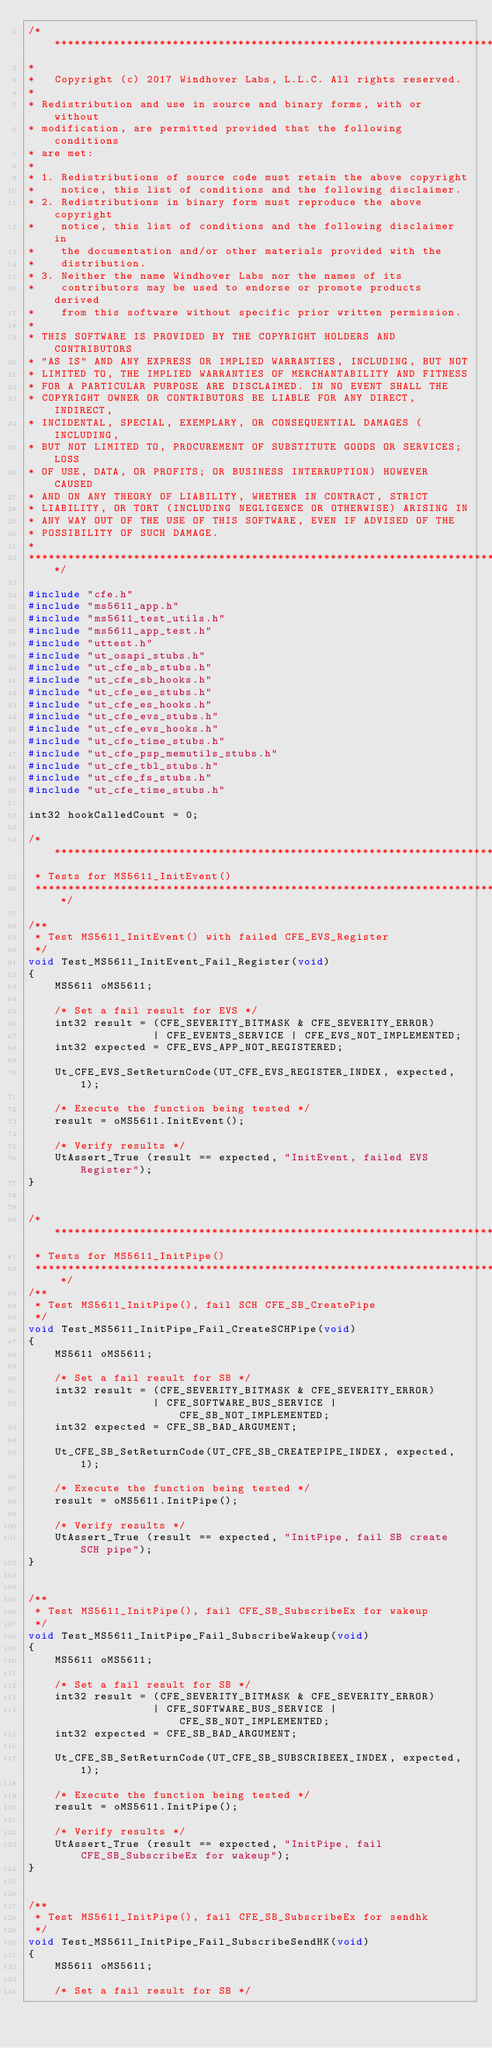<code> <loc_0><loc_0><loc_500><loc_500><_C++_>/****************************************************************************
*
*   Copyright (c) 2017 Windhover Labs, L.L.C. All rights reserved.
*
* Redistribution and use in source and binary forms, with or without
* modification, are permitted provided that the following conditions
* are met:
*
* 1. Redistributions of source code must retain the above copyright
*    notice, this list of conditions and the following disclaimer.
* 2. Redistributions in binary form must reproduce the above copyright
*    notice, this list of conditions and the following disclaimer in
*    the documentation and/or other materials provided with the
*    distribution.
* 3. Neither the name Windhover Labs nor the names of its
*    contributors may be used to endorse or promote products derived
*    from this software without specific prior written permission.
*
* THIS SOFTWARE IS PROVIDED BY THE COPYRIGHT HOLDERS AND CONTRIBUTORS
* "AS IS" AND ANY EXPRESS OR IMPLIED WARRANTIES, INCLUDING, BUT NOT
* LIMITED TO, THE IMPLIED WARRANTIES OF MERCHANTABILITY AND FITNESS
* FOR A PARTICULAR PURPOSE ARE DISCLAIMED. IN NO EVENT SHALL THE
* COPYRIGHT OWNER OR CONTRIBUTORS BE LIABLE FOR ANY DIRECT, INDIRECT,
* INCIDENTAL, SPECIAL, EXEMPLARY, OR CONSEQUENTIAL DAMAGES (INCLUDING,
* BUT NOT LIMITED TO, PROCUREMENT OF SUBSTITUTE GOODS OR SERVICES; LOSS
* OF USE, DATA, OR PROFITS; OR BUSINESS INTERRUPTION) HOWEVER CAUSED
* AND ON ANY THEORY OF LIABILITY, WHETHER IN CONTRACT, STRICT
* LIABILITY, OR TORT (INCLUDING NEGLIGENCE OR OTHERWISE) ARISING IN
* ANY WAY OUT OF THE USE OF THIS SOFTWARE, EVEN IF ADVISED OF THE
* POSSIBILITY OF SUCH DAMAGE.
*
*****************************************************************************/

#include "cfe.h"
#include "ms5611_app.h"
#include "ms5611_test_utils.h"
#include "ms5611_app_test.h"
#include "uttest.h"
#include "ut_osapi_stubs.h"
#include "ut_cfe_sb_stubs.h"
#include "ut_cfe_sb_hooks.h"
#include "ut_cfe_es_stubs.h"
#include "ut_cfe_es_hooks.h"
#include "ut_cfe_evs_stubs.h"
#include "ut_cfe_evs_hooks.h"
#include "ut_cfe_time_stubs.h"
#include "ut_cfe_psp_memutils_stubs.h"
#include "ut_cfe_tbl_stubs.h"
#include "ut_cfe_fs_stubs.h"
#include "ut_cfe_time_stubs.h"

int32 hookCalledCount = 0;

/**************************************************************************
 * Tests for MS5611_InitEvent()
 **************************************************************************/

/**
 * Test MS5611_InitEvent() with failed CFE_EVS_Register
 */
void Test_MS5611_InitEvent_Fail_Register(void)
{
    MS5611 oMS5611;

    /* Set a fail result for EVS */
    int32 result = (CFE_SEVERITY_BITMASK & CFE_SEVERITY_ERROR)
                   | CFE_EVENTS_SERVICE | CFE_EVS_NOT_IMPLEMENTED;
    int32 expected = CFE_EVS_APP_NOT_REGISTERED;

    Ut_CFE_EVS_SetReturnCode(UT_CFE_EVS_REGISTER_INDEX, expected, 1);

    /* Execute the function being tested */
    result = oMS5611.InitEvent();

    /* Verify results */
    UtAssert_True (result == expected, "InitEvent, failed EVS Register");
}


/**************************************************************************
 * Tests for MS5611_InitPipe()
 **************************************************************************/
/**
 * Test MS5611_InitPipe(), fail SCH CFE_SB_CreatePipe
 */
void Test_MS5611_InitPipe_Fail_CreateSCHPipe(void)
{
    MS5611 oMS5611;

    /* Set a fail result for SB */
    int32 result = (CFE_SEVERITY_BITMASK & CFE_SEVERITY_ERROR)
                   | CFE_SOFTWARE_BUS_SERVICE | CFE_SB_NOT_IMPLEMENTED;
    int32 expected = CFE_SB_BAD_ARGUMENT;

    Ut_CFE_SB_SetReturnCode(UT_CFE_SB_CREATEPIPE_INDEX, expected, 1);

    /* Execute the function being tested */
    result = oMS5611.InitPipe();

    /* Verify results */
    UtAssert_True (result == expected, "InitPipe, fail SB create SCH pipe");
}


/**
 * Test MS5611_InitPipe(), fail CFE_SB_SubscribeEx for wakeup
 */
void Test_MS5611_InitPipe_Fail_SubscribeWakeup(void)
{
    MS5611 oMS5611;

    /* Set a fail result for SB */
    int32 result = (CFE_SEVERITY_BITMASK & CFE_SEVERITY_ERROR)
                   | CFE_SOFTWARE_BUS_SERVICE | CFE_SB_NOT_IMPLEMENTED;
    int32 expected = CFE_SB_BAD_ARGUMENT;

    Ut_CFE_SB_SetReturnCode(UT_CFE_SB_SUBSCRIBEEX_INDEX, expected, 1);

    /* Execute the function being tested */
    result = oMS5611.InitPipe();

    /* Verify results */
    UtAssert_True (result == expected, "InitPipe, fail CFE_SB_SubscribeEx for wakeup");
}


/**
 * Test MS5611_InitPipe(), fail CFE_SB_SubscribeEx for sendhk
 */
void Test_MS5611_InitPipe_Fail_SubscribeSendHK(void)
{
    MS5611 oMS5611;

    /* Set a fail result for SB */</code> 